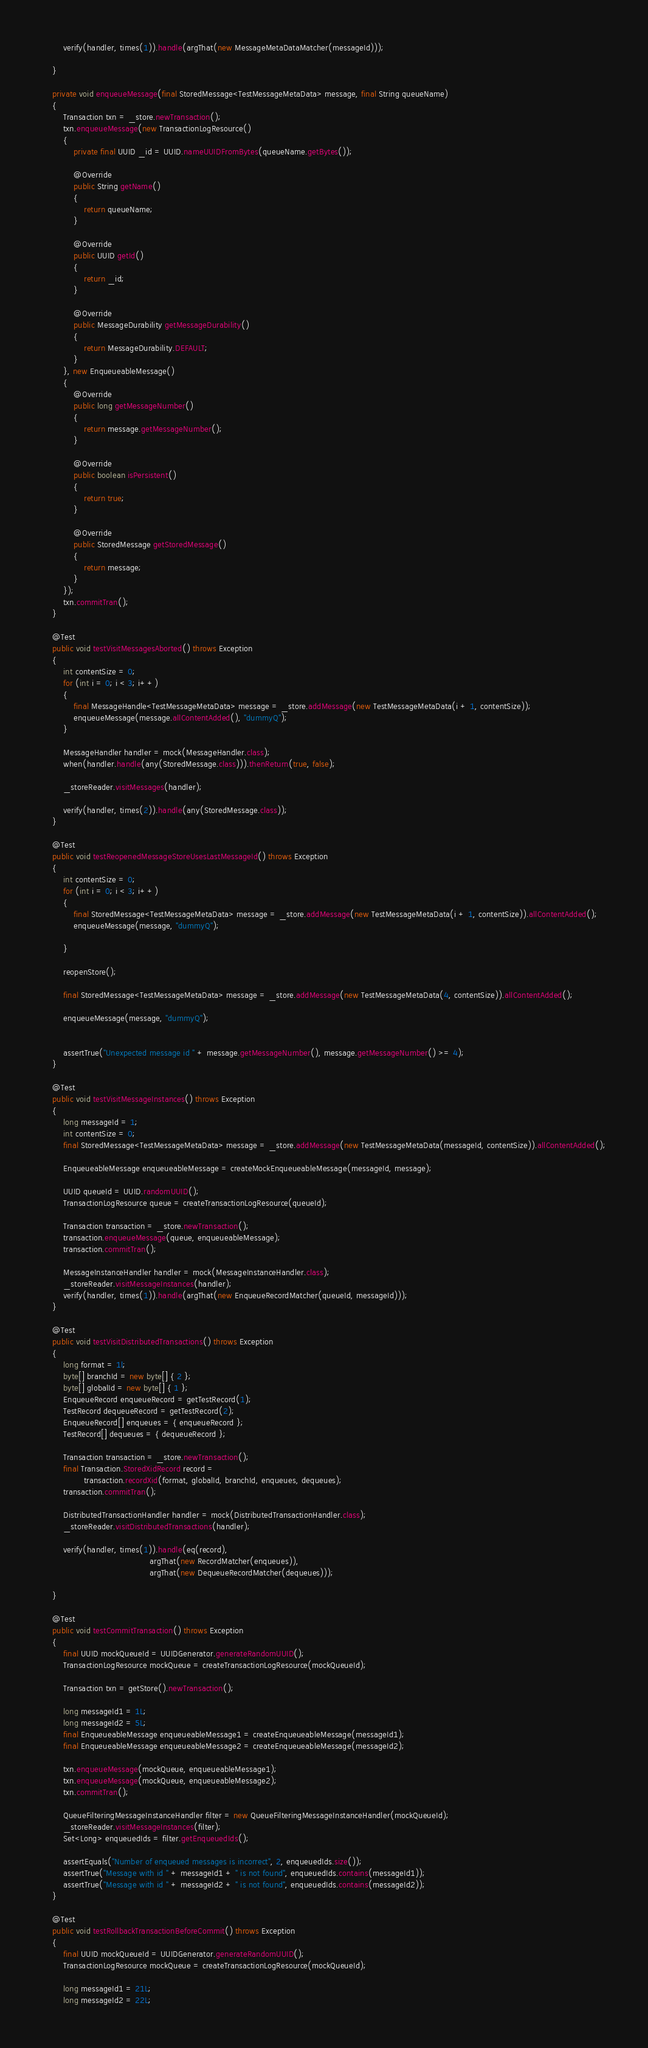Convert code to text. <code><loc_0><loc_0><loc_500><loc_500><_Java_>
        verify(handler, times(1)).handle(argThat(new MessageMetaDataMatcher(messageId)));

    }

    private void enqueueMessage(final StoredMessage<TestMessageMetaData> message, final String queueName)
    {
        Transaction txn = _store.newTransaction();
        txn.enqueueMessage(new TransactionLogResource()
        {
            private final UUID _id = UUID.nameUUIDFromBytes(queueName.getBytes());

            @Override
            public String getName()
            {
                return queueName;
            }

            @Override
            public UUID getId()
            {
                return _id;
            }

            @Override
            public MessageDurability getMessageDurability()
            {
                return MessageDurability.DEFAULT;
            }
        }, new EnqueueableMessage()
        {
            @Override
            public long getMessageNumber()
            {
                return message.getMessageNumber();
            }

            @Override
            public boolean isPersistent()
            {
                return true;
            }

            @Override
            public StoredMessage getStoredMessage()
            {
                return message;
            }
        });
        txn.commitTran();
    }

    @Test
    public void testVisitMessagesAborted() throws Exception
    {
        int contentSize = 0;
        for (int i = 0; i < 3; i++)
        {
            final MessageHandle<TestMessageMetaData> message = _store.addMessage(new TestMessageMetaData(i + 1, contentSize));
            enqueueMessage(message.allContentAdded(), "dummyQ");
        }

        MessageHandler handler = mock(MessageHandler.class);
        when(handler.handle(any(StoredMessage.class))).thenReturn(true, false);

        _storeReader.visitMessages(handler);

        verify(handler, times(2)).handle(any(StoredMessage.class));
    }

    @Test
    public void testReopenedMessageStoreUsesLastMessageId() throws Exception
    {
        int contentSize = 0;
        for (int i = 0; i < 3; i++)
        {
            final StoredMessage<TestMessageMetaData> message = _store.addMessage(new TestMessageMetaData(i + 1, contentSize)).allContentAdded();
            enqueueMessage(message, "dummyQ");

        }

        reopenStore();

        final StoredMessage<TestMessageMetaData> message = _store.addMessage(new TestMessageMetaData(4, contentSize)).allContentAdded();

        enqueueMessage(message, "dummyQ");


        assertTrue("Unexpected message id " + message.getMessageNumber(), message.getMessageNumber() >= 4);
    }

    @Test
    public void testVisitMessageInstances() throws Exception
    {
        long messageId = 1;
        int contentSize = 0;
        final StoredMessage<TestMessageMetaData> message = _store.addMessage(new TestMessageMetaData(messageId, contentSize)).allContentAdded();

        EnqueueableMessage enqueueableMessage = createMockEnqueueableMessage(messageId, message);

        UUID queueId = UUID.randomUUID();
        TransactionLogResource queue = createTransactionLogResource(queueId);

        Transaction transaction = _store.newTransaction();
        transaction.enqueueMessage(queue, enqueueableMessage);
        transaction.commitTran();

        MessageInstanceHandler handler = mock(MessageInstanceHandler.class);
        _storeReader.visitMessageInstances(handler);
        verify(handler, times(1)).handle(argThat(new EnqueueRecordMatcher(queueId, messageId)));
    }

    @Test
    public void testVisitDistributedTransactions() throws Exception
    {
        long format = 1l;
        byte[] branchId = new byte[] { 2 };
        byte[] globalId = new byte[] { 1 };
        EnqueueRecord enqueueRecord = getTestRecord(1);
        TestRecord dequeueRecord = getTestRecord(2);
        EnqueueRecord[] enqueues = { enqueueRecord };
        TestRecord[] dequeues = { dequeueRecord };

        Transaction transaction = _store.newTransaction();
        final Transaction.StoredXidRecord record =
                transaction.recordXid(format, globalId, branchId, enqueues, dequeues);
        transaction.commitTran();

        DistributedTransactionHandler handler = mock(DistributedTransactionHandler.class);
        _storeReader.visitDistributedTransactions(handler);

        verify(handler, times(1)).handle(eq(record),
                                         argThat(new RecordMatcher(enqueues)),
                                         argThat(new DequeueRecordMatcher(dequeues)));

    }

    @Test
    public void testCommitTransaction() throws Exception
    {
        final UUID mockQueueId = UUIDGenerator.generateRandomUUID();
        TransactionLogResource mockQueue = createTransactionLogResource(mockQueueId);

        Transaction txn = getStore().newTransaction();

        long messageId1 = 1L;
        long messageId2 = 5L;
        final EnqueueableMessage enqueueableMessage1 = createEnqueueableMessage(messageId1);
        final EnqueueableMessage enqueueableMessage2 = createEnqueueableMessage(messageId2);

        txn.enqueueMessage(mockQueue, enqueueableMessage1);
        txn.enqueueMessage(mockQueue, enqueueableMessage2);
        txn.commitTran();

        QueueFilteringMessageInstanceHandler filter = new QueueFilteringMessageInstanceHandler(mockQueueId);
        _storeReader.visitMessageInstances(filter);
        Set<Long> enqueuedIds = filter.getEnqueuedIds();

        assertEquals("Number of enqueued messages is incorrect", 2, enqueuedIds.size());
        assertTrue("Message with id " + messageId1 + " is not found", enqueuedIds.contains(messageId1));
        assertTrue("Message with id " + messageId2 + " is not found", enqueuedIds.contains(messageId2));
    }

    @Test
    public void testRollbackTransactionBeforeCommit() throws Exception
    {
        final UUID mockQueueId = UUIDGenerator.generateRandomUUID();
        TransactionLogResource mockQueue = createTransactionLogResource(mockQueueId);

        long messageId1 = 21L;
        long messageId2 = 22L;</code> 